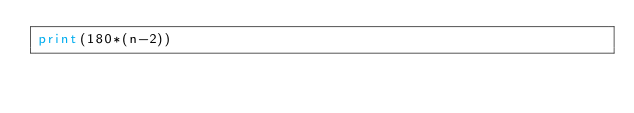Convert code to text. <code><loc_0><loc_0><loc_500><loc_500><_Python_>print(180*(n-2))</code> 